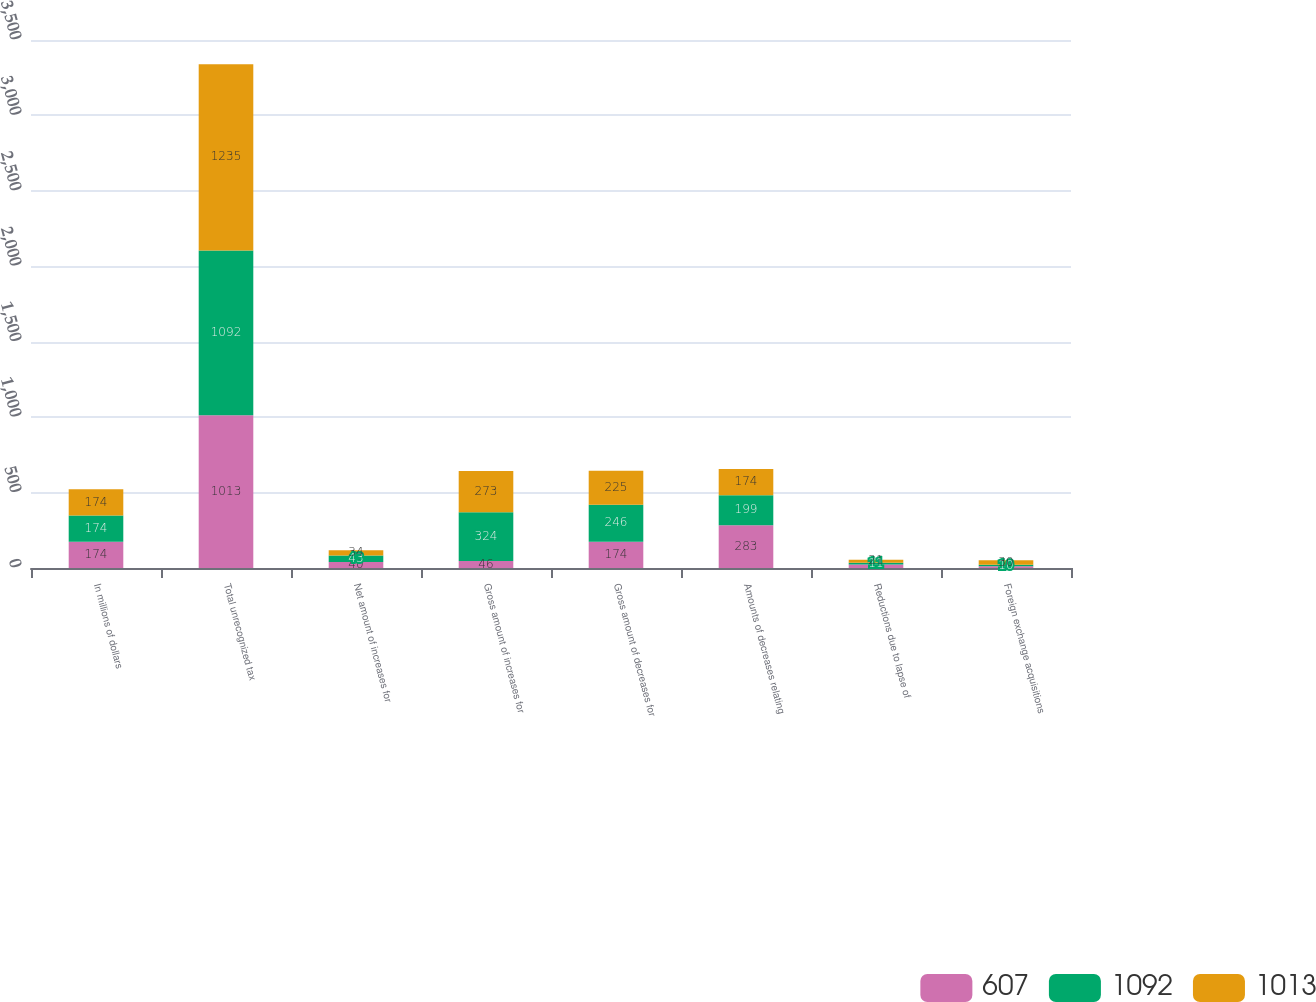Convert chart to OTSL. <chart><loc_0><loc_0><loc_500><loc_500><stacked_bar_chart><ecel><fcel>In millions of dollars<fcel>Total unrecognized tax<fcel>Net amount of increases for<fcel>Gross amount of increases for<fcel>Gross amount of decreases for<fcel>Amounts of decreases relating<fcel>Reductions due to lapse of<fcel>Foreign exchange acquisitions<nl><fcel>607<fcel>174<fcel>1013<fcel>40<fcel>46<fcel>174<fcel>283<fcel>23<fcel>12<nl><fcel>1092<fcel>174<fcel>1092<fcel>43<fcel>324<fcel>246<fcel>199<fcel>11<fcel>10<nl><fcel>1013<fcel>174<fcel>1235<fcel>34<fcel>273<fcel>225<fcel>174<fcel>21<fcel>30<nl></chart> 